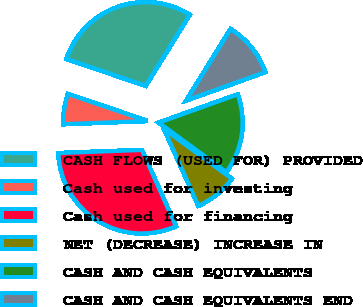Convert chart. <chart><loc_0><loc_0><loc_500><loc_500><pie_chart><fcel>CASH FLOWS (USED FOR) PROVIDED<fcel>Cash used for investing<fcel>Cash used for financing<fcel>NET (DECREASE) INCREASE IN<fcel>CASH AND CASH EQUIVALENTS<fcel>CASH AND CASH EQUIVALENTS END<nl><fcel>28.63%<fcel>5.81%<fcel>31.08%<fcel>8.25%<fcel>15.54%<fcel>10.69%<nl></chart> 